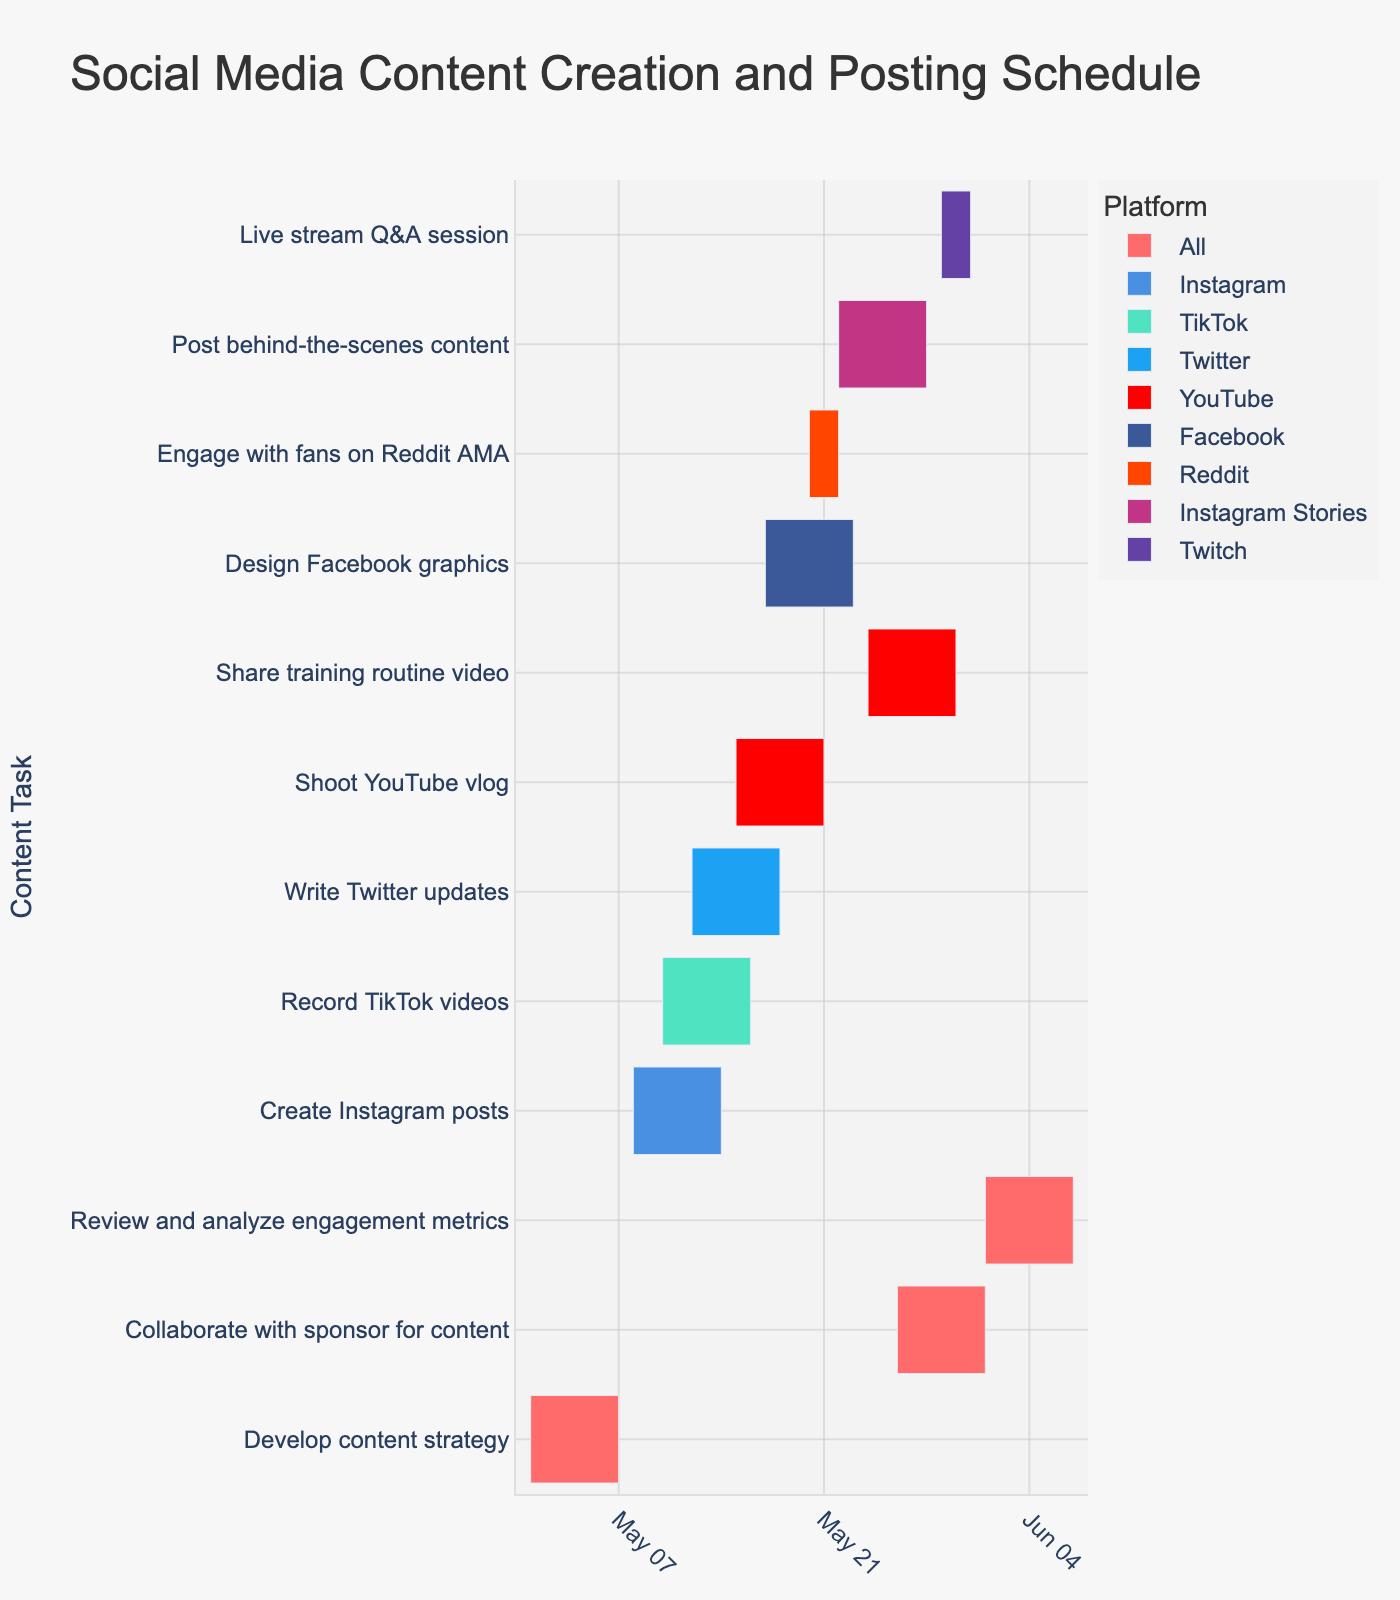What's the title of the figure? The title is usually the most prominent text at the top of the figure, providing a summary of the chart's content. The title of this Gantt Chart is "Social Media Content Creation and Posting Schedule."
Answer: Social Media Content Creation and Posting Schedule Which platform has the most tasks scheduled? To find the platform with the most tasks, count how many times each platform appears in the "Platform" column in the figure. "All" has the same frequency as "YouTube".
Answer: All How many days does the "Develop content strategy" task last? Calculate the number of days from the start date to the end date by counting the days between May 1 and May 7, inclusive. This task spans from May 1 to May 7 (7 days).
Answer: 7 Which task starts immediately after "Create Instagram posts"? Look at the tasks and their start dates. "Create Instagram posts" ends on May 14; the task starting right after is "Record TikTok videos" which starts on May 10. However, we need to find a task that starts the day after, so "Write Twitter updates" is the next relevant task starting on May 12.
Answer: Write Twitter updates Which task has the shortest duration and what is its duration? Examine the "Start Date" and "End Date" for each task, and calculate the difference. "Engage with fans on Reddit AMA" spans just 3 days, which is the shortest duration.
Answer: Engage with fans on Reddit AMA (3 days) Between "Shoot YouTube vlog" and "Design Facebook graphics," which one finishes first? Compare the end dates of both tasks. "Shoot YouTube vlog" ends on May 21, while "Design Facebook graphics" ends on May 23. Thus, the YouTube task finishes first.
Answer: Shoot YouTube vlog How many tasks are scheduled to be worked on during May 20? Identify tasks by checking their start and end dates to see which include May 20. The tasks are "Shoot YouTube vlog," "Design Facebook graphics," and "Engage with fans on Reddit AMA." Thus, there are three tasks on that date.
Answer: 3 Between which dates does the task "Collaborate with sponsor for content" take place? Simply find the start and end date of the "Collaborate with sponsor for content" task from the figure. It starts on May 26 and ends on June 1.
Answer: May 26 to June 1 Which tasks overlap with the "Post behind-the-scenes content" task? "Post behind-the-scenes content" runs from May 22 to May 28. Look for tasks that have timelines intersecting these dates. Overlapping tasks are "Design Facebook graphics," "Share training routine video," and "Collaborate with sponsor for content."
Answer: Design Facebook graphics, Share training routine video, Collaborate with sponsor for content How long after the start of the "Share training routine video" before the "Review and analyze engagement metrics" begins? "Share training routine video" starts on May 24, and "Review and analyze engagement metrics" begins on June 1. Calculate the difference between the start dates.
Answer: 8 days 